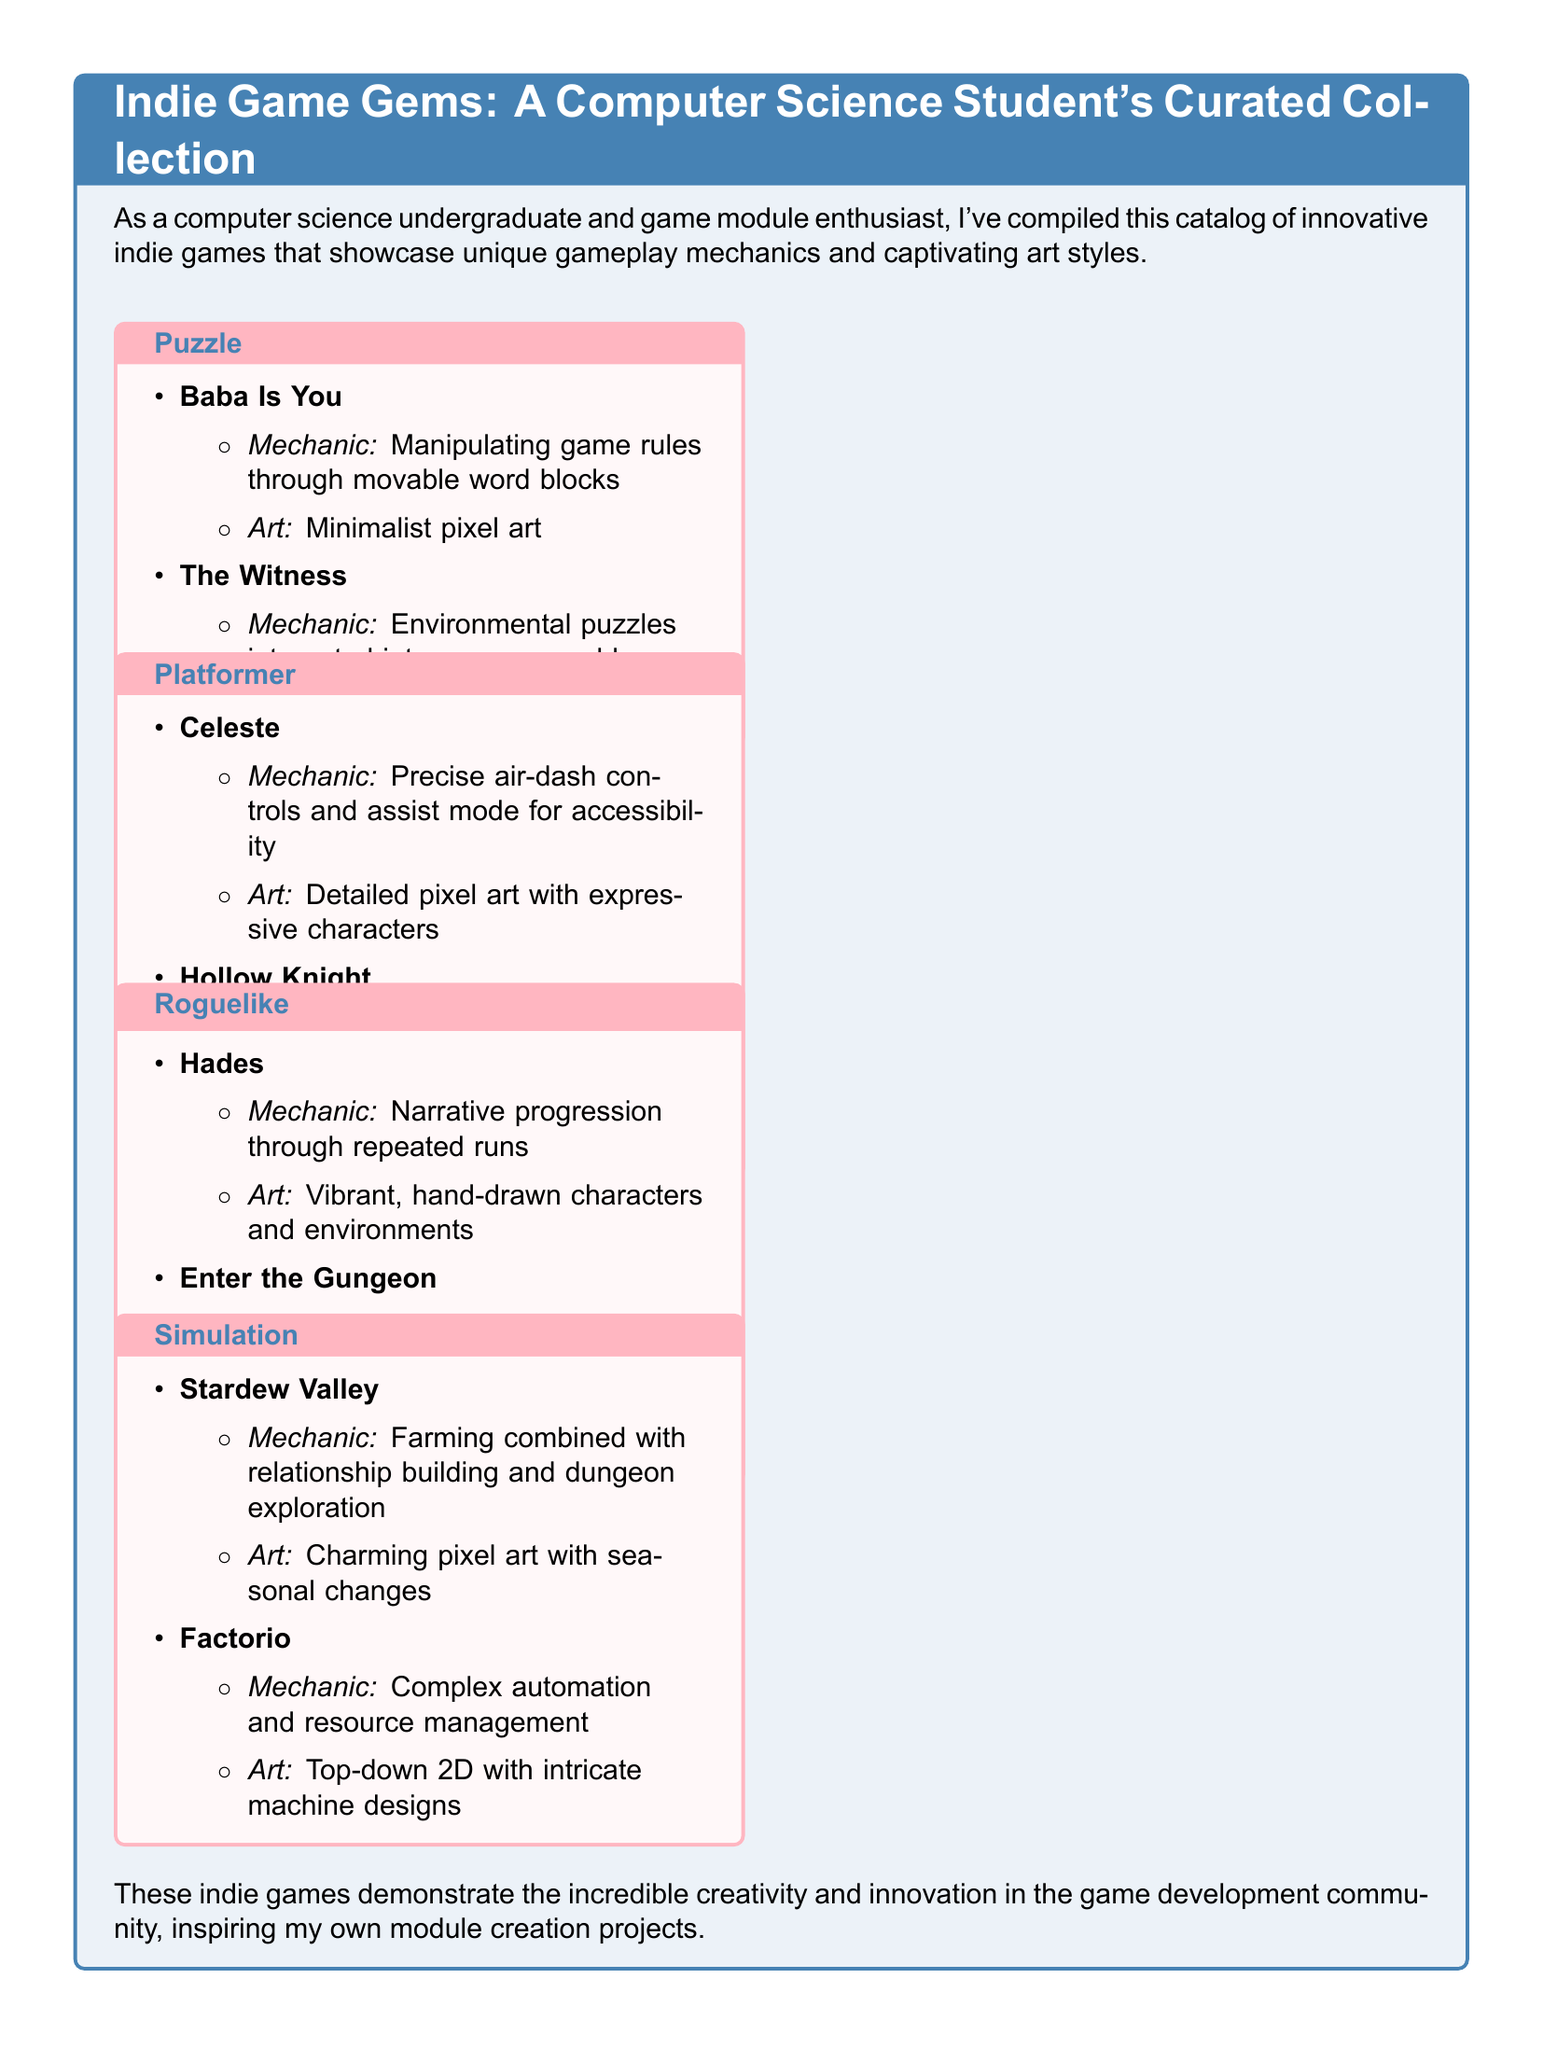What is the first puzzle game listed? The first game in the puzzle category is presented in the document as "Baba Is You".
Answer: Baba Is You Which game features precise air-dash controls? The document mentions "Celeste" as having precise air-dash controls and an assist mode for accessibility.
Answer: Celeste What is the unique mechanic of Hades? The mechanic of "Hades" involves narrative progression through repeated runs according to the document.
Answer: Narrative progression through repeated runs What type of art style does Stardew Valley use? The document describes the art style of "Stardew Valley" as charming pixel art with seasonal changes.
Answer: Charming pixel art with seasonal changes How many roguelike games are listed? The document lists two roguelike games in total: "Hades" and "Enter the Gungeon".
Answer: 2 Which game features environmental puzzles? The document states that "The Witness" includes environmental puzzles integrated into an open world.
Answer: The Witness What category does "Hollow Knight" belong to? According to the document, "Hollow Knight" is classified as a Metroidvania exploration game under the platformer category.
Answer: Platformer What is the art style of Factorio? The document characterizes "Factorio" as having intricate machine designs in a top-down 2D art style.
Answer: Top-down 2D with intricate machine designs 